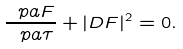Convert formula to latex. <formula><loc_0><loc_0><loc_500><loc_500>\frac { \ p a F } { \ p a \tau } + | D F | ^ { 2 } = 0 .</formula> 